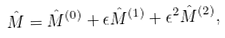Convert formula to latex. <formula><loc_0><loc_0><loc_500><loc_500>\hat { M } = \hat { M } ^ { ( 0 ) } + \epsilon \hat { M } ^ { ( 1 ) } + \epsilon ^ { 2 } \hat { M } ^ { ( 2 ) } ,</formula> 